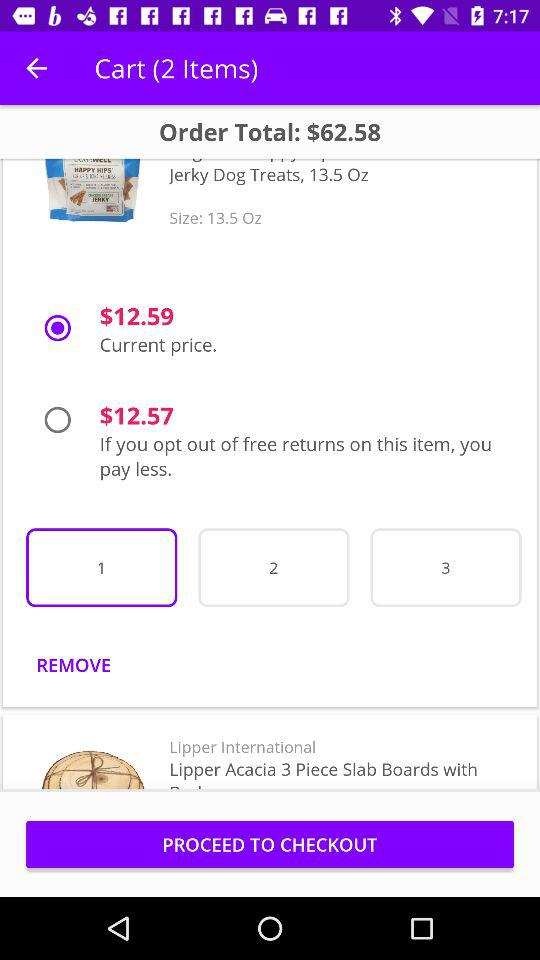What's the total price of the order? The total price of the order is $62.58. 